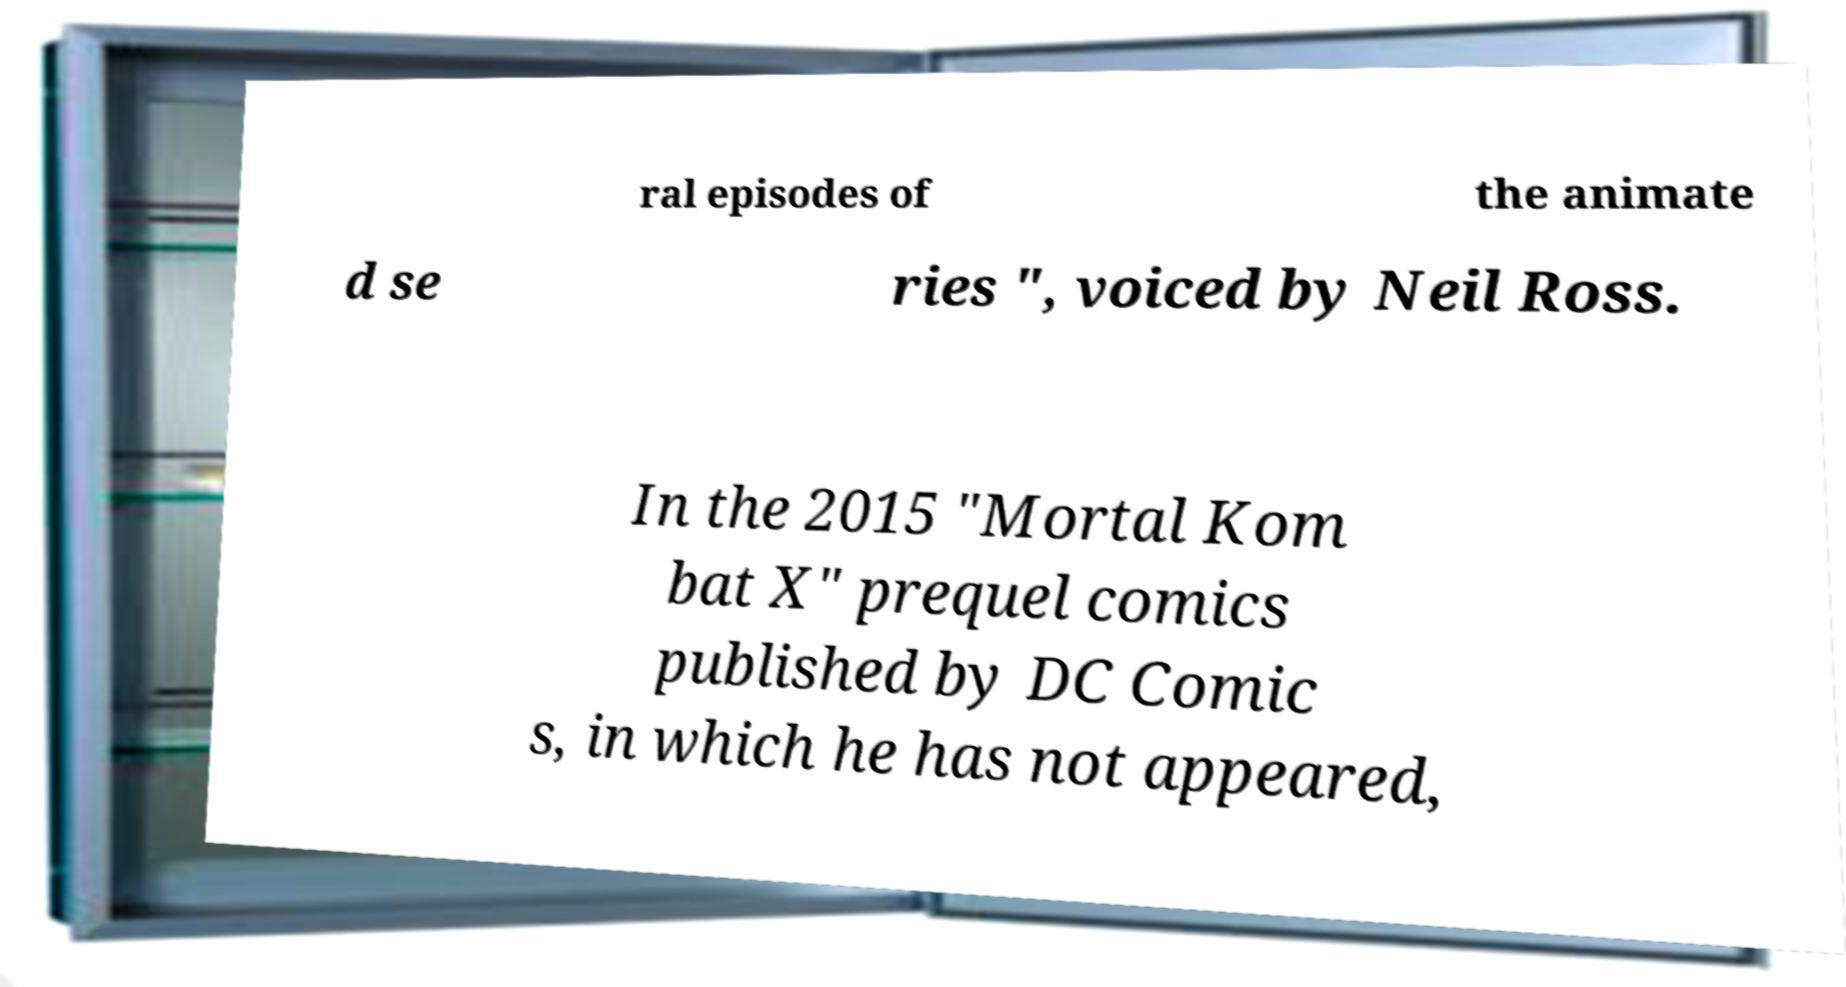Could you extract and type out the text from this image? ral episodes of the animate d se ries ", voiced by Neil Ross. In the 2015 "Mortal Kom bat X" prequel comics published by DC Comic s, in which he has not appeared, 